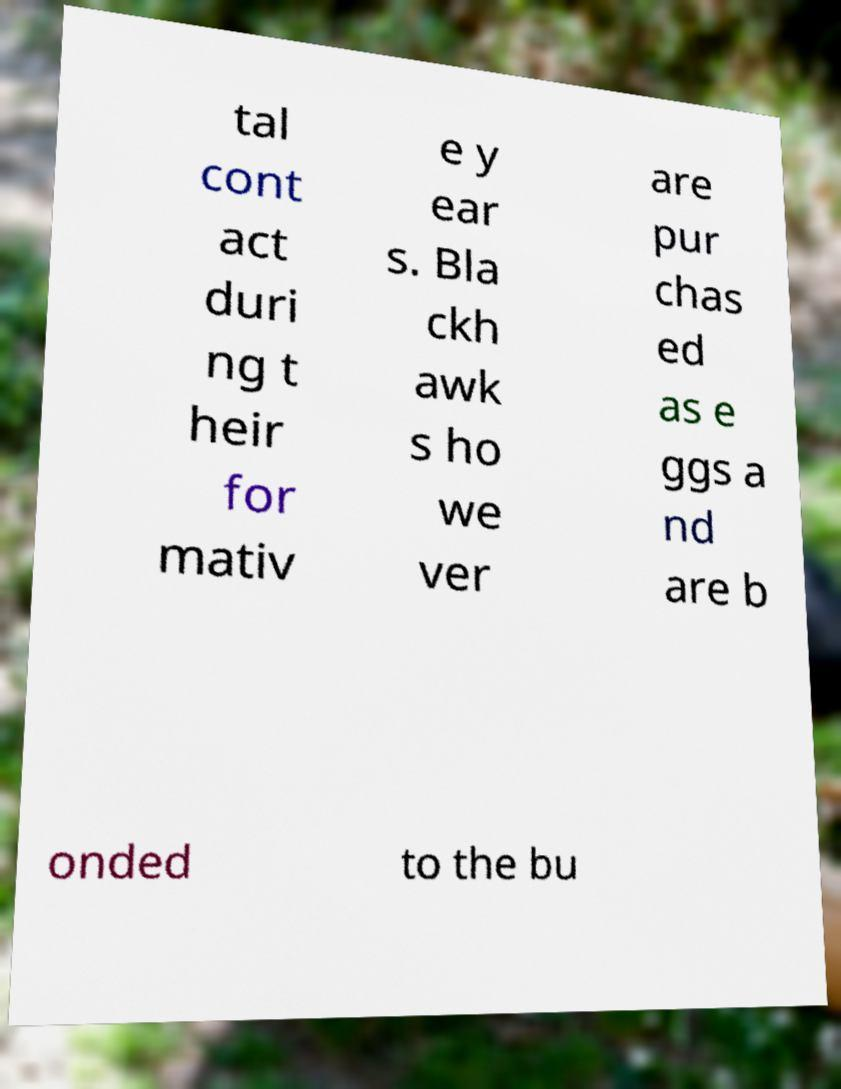Could you assist in decoding the text presented in this image and type it out clearly? tal cont act duri ng t heir for mativ e y ear s. Bla ckh awk s ho we ver are pur chas ed as e ggs a nd are b onded to the bu 